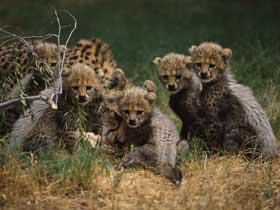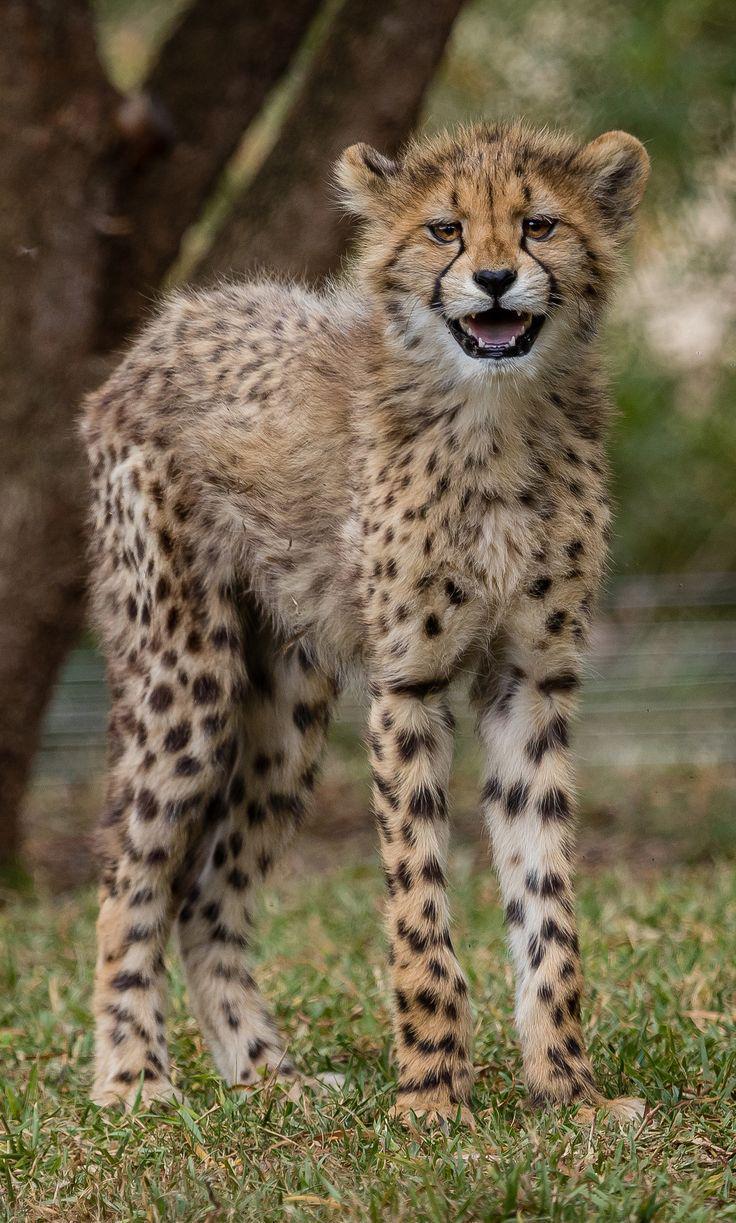The first image is the image on the left, the second image is the image on the right. Examine the images to the left and right. Is the description "There are exactly eight cheetahs." accurate? Answer yes or no. No. The first image is the image on the left, the second image is the image on the right. Considering the images on both sides, is "An image contains only a non-standing adult wild cat and one kitten, posed with their faces close together." valid? Answer yes or no. No. 